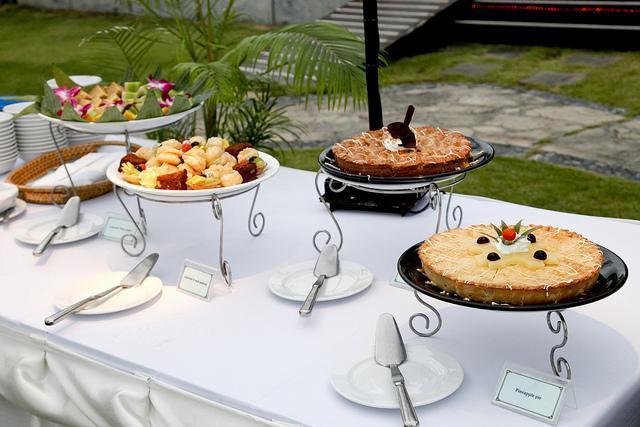How many pie cutter do you see?
Give a very brief answer. 4. How many dining tables are visible?
Give a very brief answer. 1. How many people are holding camera?
Give a very brief answer. 0. 